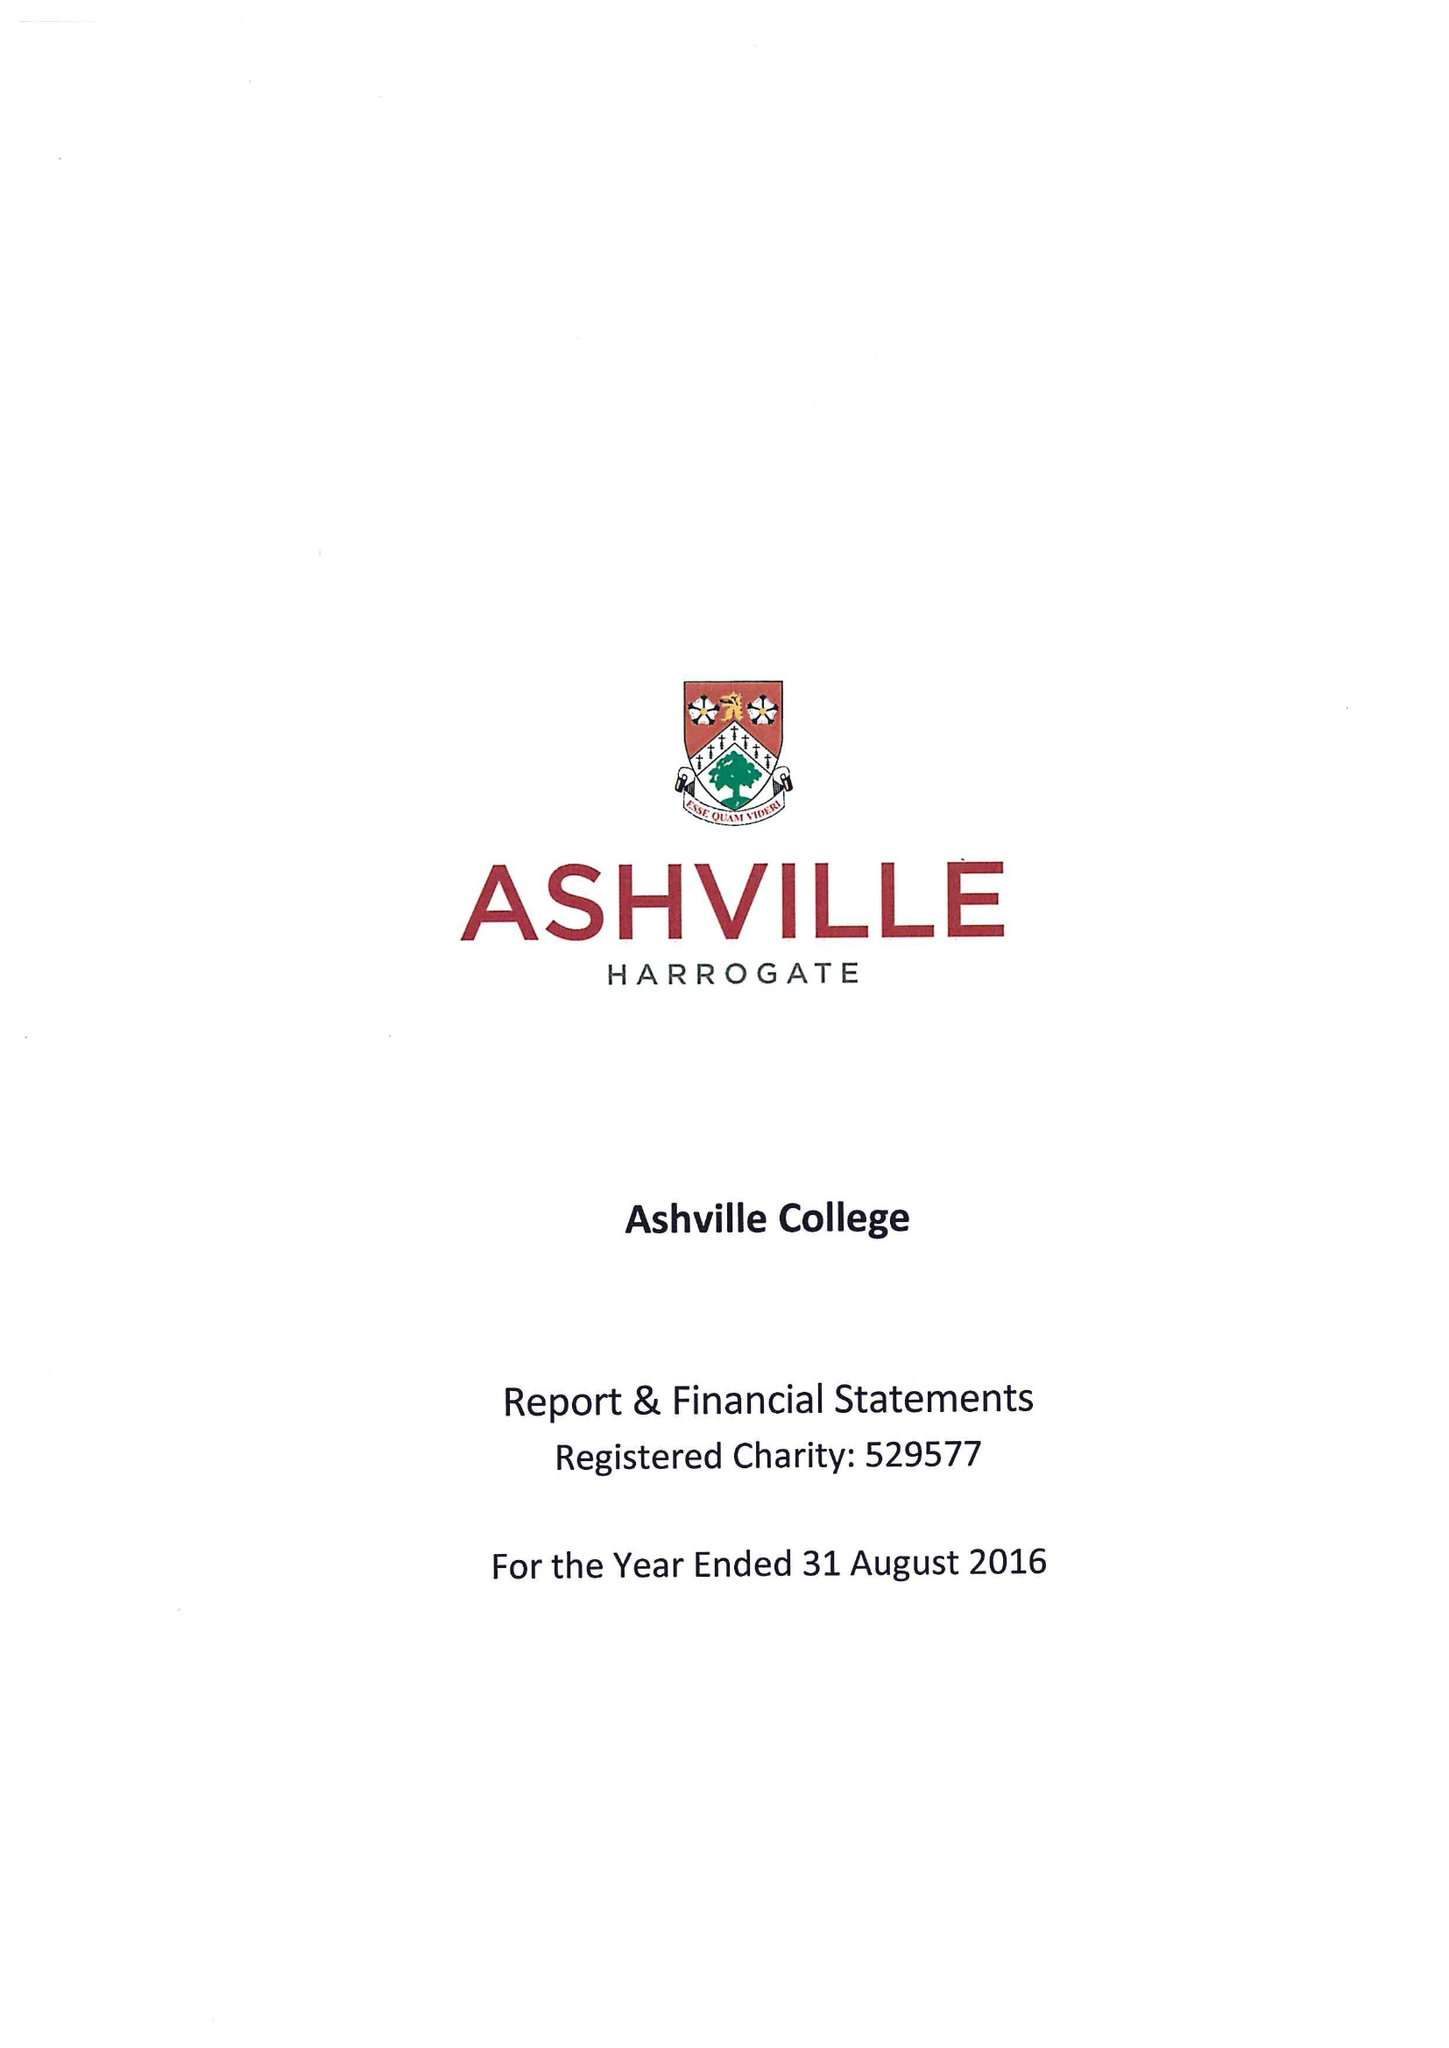What is the value for the spending_annually_in_british_pounds?
Answer the question using a single word or phrase. 11276236.00 